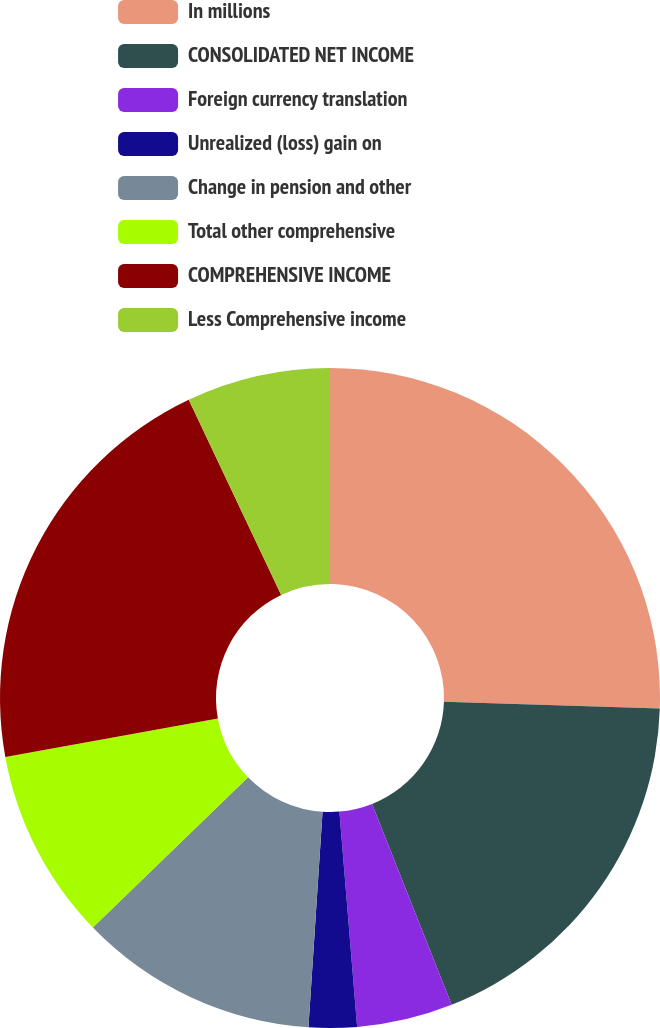<chart> <loc_0><loc_0><loc_500><loc_500><pie_chart><fcel>In millions<fcel>CONSOLIDATED NET INCOME<fcel>Foreign currency translation<fcel>Unrealized (loss) gain on<fcel>Change in pension and other<fcel>Total other comprehensive<fcel>COMPREHENSIVE INCOME<fcel>Less Comprehensive income<nl><fcel>25.51%<fcel>18.48%<fcel>4.7%<fcel>2.35%<fcel>11.72%<fcel>9.38%<fcel>20.82%<fcel>7.04%<nl></chart> 